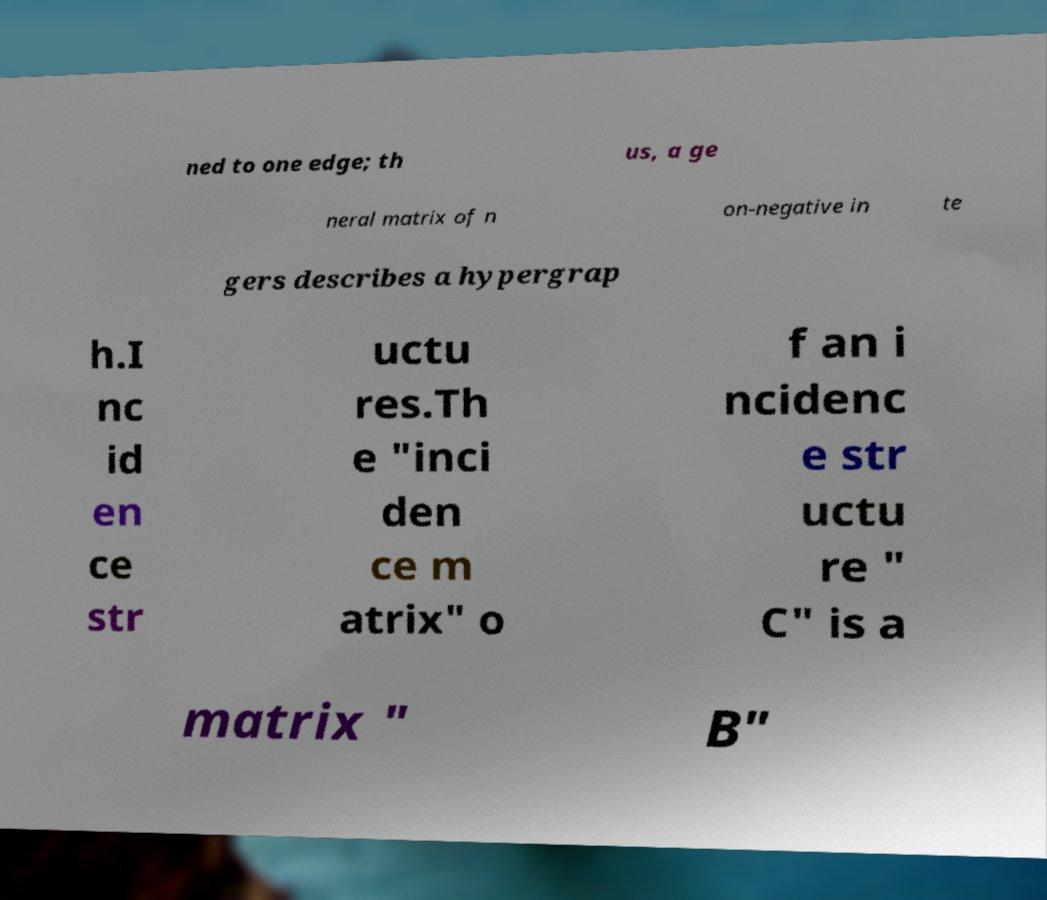Can you read and provide the text displayed in the image?This photo seems to have some interesting text. Can you extract and type it out for me? ned to one edge; th us, a ge neral matrix of n on-negative in te gers describes a hypergrap h.I nc id en ce str uctu res.Th e "inci den ce m atrix" o f an i ncidenc e str uctu re " C" is a matrix " B" 